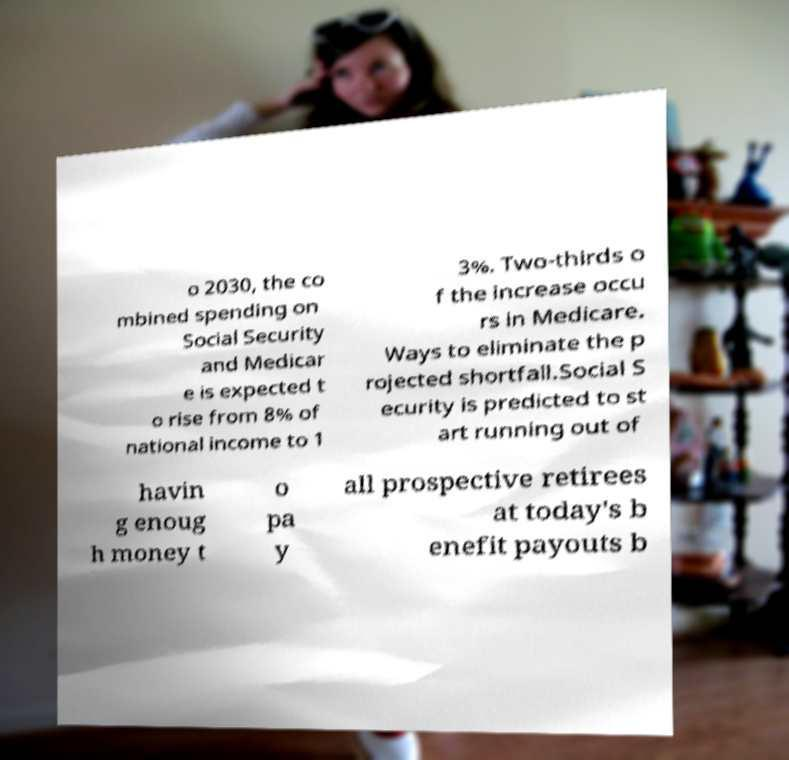There's text embedded in this image that I need extracted. Can you transcribe it verbatim? o 2030, the co mbined spending on Social Security and Medicar e is expected t o rise from 8% of national income to 1 3%. Two-thirds o f the increase occu rs in Medicare. Ways to eliminate the p rojected shortfall.Social S ecurity is predicted to st art running out of havin g enoug h money t o pa y all prospective retirees at today's b enefit payouts b 